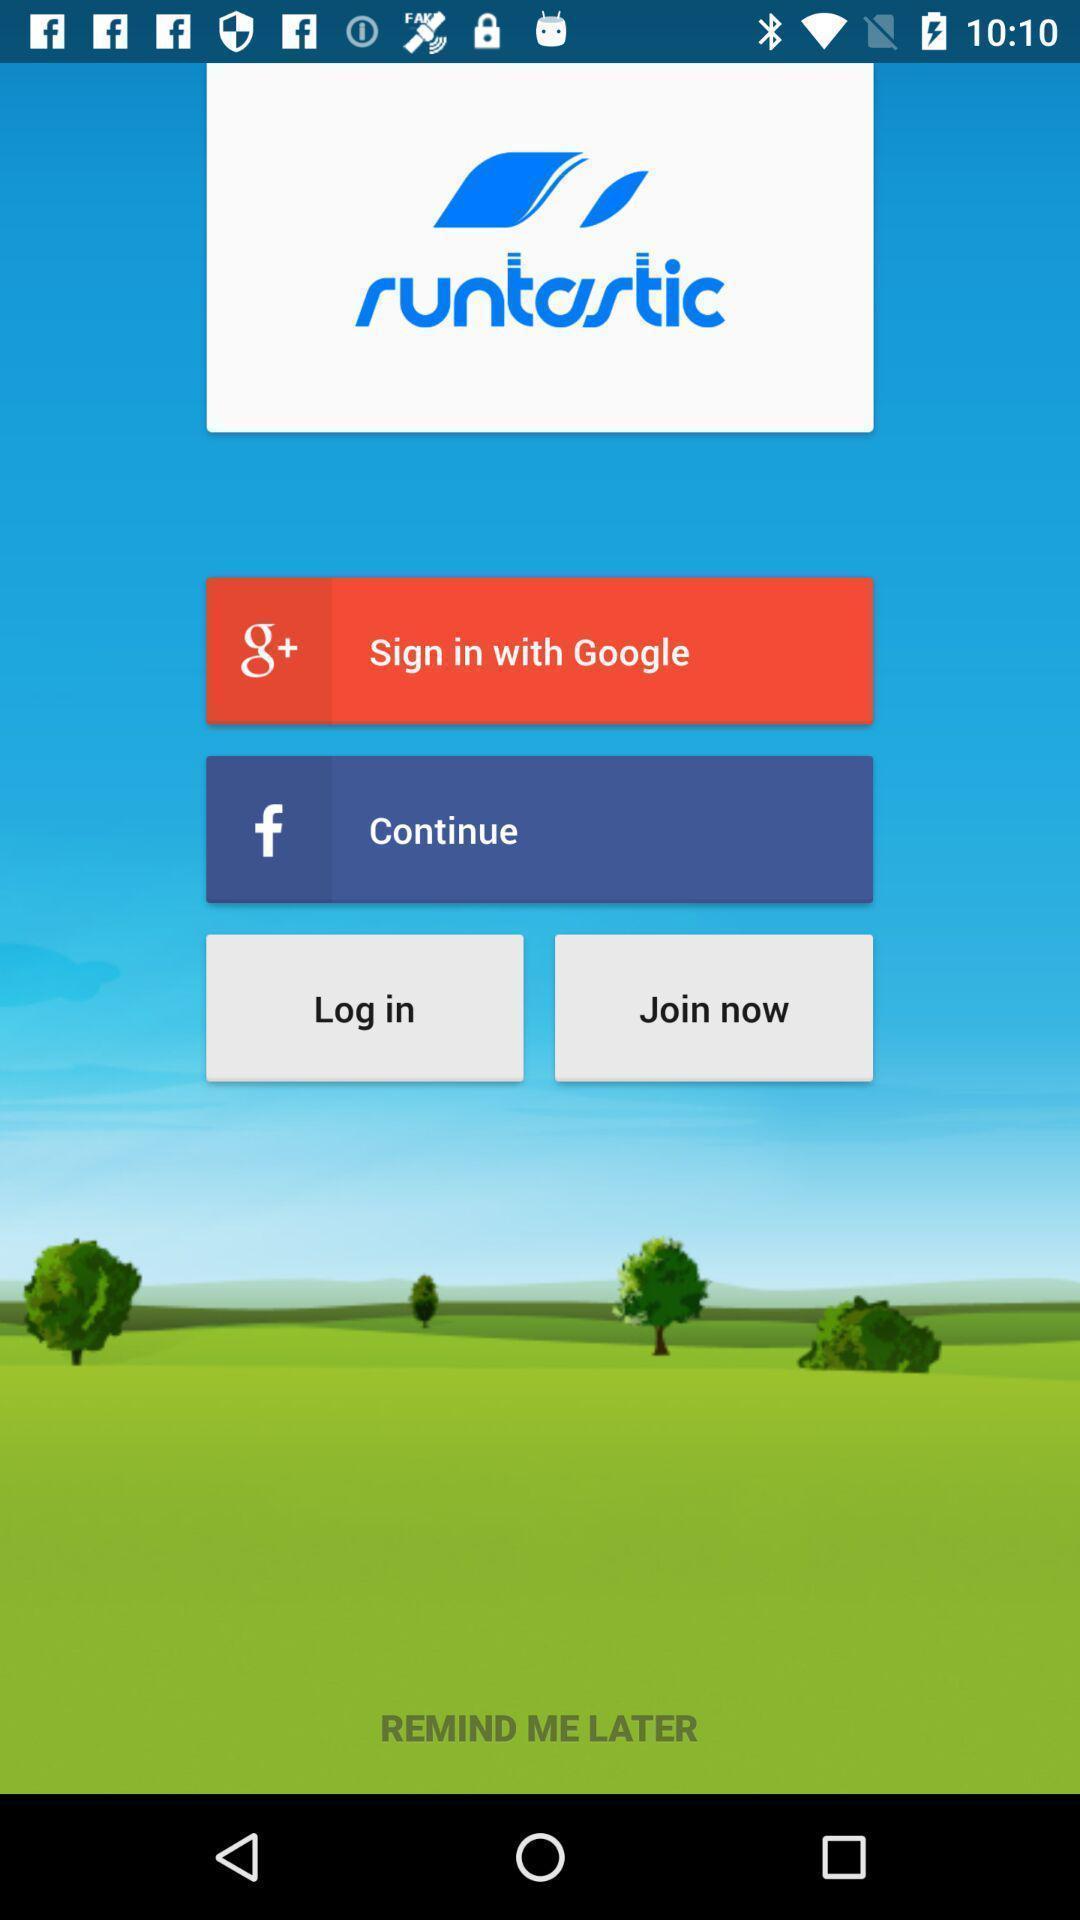Give me a summary of this screen capture. Page displaying different login options. 